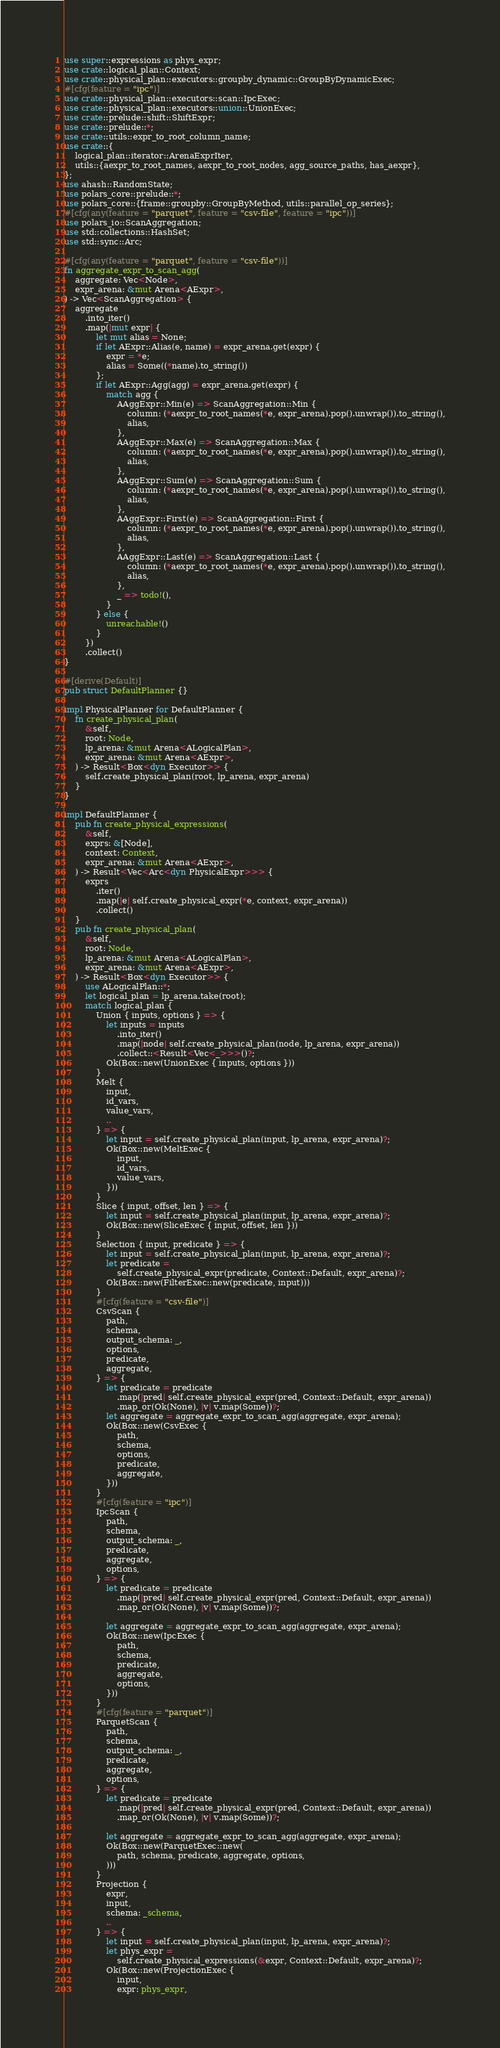<code> <loc_0><loc_0><loc_500><loc_500><_Rust_>use super::expressions as phys_expr;
use crate::logical_plan::Context;
use crate::physical_plan::executors::groupby_dynamic::GroupByDynamicExec;
#[cfg(feature = "ipc")]
use crate::physical_plan::executors::scan::IpcExec;
use crate::physical_plan::executors::union::UnionExec;
use crate::prelude::shift::ShiftExpr;
use crate::prelude::*;
use crate::utils::expr_to_root_column_name;
use crate::{
    logical_plan::iterator::ArenaExprIter,
    utils::{aexpr_to_root_names, aexpr_to_root_nodes, agg_source_paths, has_aexpr},
};
use ahash::RandomState;
use polars_core::prelude::*;
use polars_core::{frame::groupby::GroupByMethod, utils::parallel_op_series};
#[cfg(any(feature = "parquet", feature = "csv-file", feature = "ipc"))]
use polars_io::ScanAggregation;
use std::collections::HashSet;
use std::sync::Arc;

#[cfg(any(feature = "parquet", feature = "csv-file"))]
fn aggregate_expr_to_scan_agg(
    aggregate: Vec<Node>,
    expr_arena: &mut Arena<AExpr>,
) -> Vec<ScanAggregation> {
    aggregate
        .into_iter()
        .map(|mut expr| {
            let mut alias = None;
            if let AExpr::Alias(e, name) = expr_arena.get(expr) {
                expr = *e;
                alias = Some((*name).to_string())
            };
            if let AExpr::Agg(agg) = expr_arena.get(expr) {
                match agg {
                    AAggExpr::Min(e) => ScanAggregation::Min {
                        column: (*aexpr_to_root_names(*e, expr_arena).pop().unwrap()).to_string(),
                        alias,
                    },
                    AAggExpr::Max(e) => ScanAggregation::Max {
                        column: (*aexpr_to_root_names(*e, expr_arena).pop().unwrap()).to_string(),
                        alias,
                    },
                    AAggExpr::Sum(e) => ScanAggregation::Sum {
                        column: (*aexpr_to_root_names(*e, expr_arena).pop().unwrap()).to_string(),
                        alias,
                    },
                    AAggExpr::First(e) => ScanAggregation::First {
                        column: (*aexpr_to_root_names(*e, expr_arena).pop().unwrap()).to_string(),
                        alias,
                    },
                    AAggExpr::Last(e) => ScanAggregation::Last {
                        column: (*aexpr_to_root_names(*e, expr_arena).pop().unwrap()).to_string(),
                        alias,
                    },
                    _ => todo!(),
                }
            } else {
                unreachable!()
            }
        })
        .collect()
}

#[derive(Default)]
pub struct DefaultPlanner {}

impl PhysicalPlanner for DefaultPlanner {
    fn create_physical_plan(
        &self,
        root: Node,
        lp_arena: &mut Arena<ALogicalPlan>,
        expr_arena: &mut Arena<AExpr>,
    ) -> Result<Box<dyn Executor>> {
        self.create_physical_plan(root, lp_arena, expr_arena)
    }
}

impl DefaultPlanner {
    pub fn create_physical_expressions(
        &self,
        exprs: &[Node],
        context: Context,
        expr_arena: &mut Arena<AExpr>,
    ) -> Result<Vec<Arc<dyn PhysicalExpr>>> {
        exprs
            .iter()
            .map(|e| self.create_physical_expr(*e, context, expr_arena))
            .collect()
    }
    pub fn create_physical_plan(
        &self,
        root: Node,
        lp_arena: &mut Arena<ALogicalPlan>,
        expr_arena: &mut Arena<AExpr>,
    ) -> Result<Box<dyn Executor>> {
        use ALogicalPlan::*;
        let logical_plan = lp_arena.take(root);
        match logical_plan {
            Union { inputs, options } => {
                let inputs = inputs
                    .into_iter()
                    .map(|node| self.create_physical_plan(node, lp_arena, expr_arena))
                    .collect::<Result<Vec<_>>>()?;
                Ok(Box::new(UnionExec { inputs, options }))
            }
            Melt {
                input,
                id_vars,
                value_vars,
                ..
            } => {
                let input = self.create_physical_plan(input, lp_arena, expr_arena)?;
                Ok(Box::new(MeltExec {
                    input,
                    id_vars,
                    value_vars,
                }))
            }
            Slice { input, offset, len } => {
                let input = self.create_physical_plan(input, lp_arena, expr_arena)?;
                Ok(Box::new(SliceExec { input, offset, len }))
            }
            Selection { input, predicate } => {
                let input = self.create_physical_plan(input, lp_arena, expr_arena)?;
                let predicate =
                    self.create_physical_expr(predicate, Context::Default, expr_arena)?;
                Ok(Box::new(FilterExec::new(predicate, input)))
            }
            #[cfg(feature = "csv-file")]
            CsvScan {
                path,
                schema,
                output_schema: _,
                options,
                predicate,
                aggregate,
            } => {
                let predicate = predicate
                    .map(|pred| self.create_physical_expr(pred, Context::Default, expr_arena))
                    .map_or(Ok(None), |v| v.map(Some))?;
                let aggregate = aggregate_expr_to_scan_agg(aggregate, expr_arena);
                Ok(Box::new(CsvExec {
                    path,
                    schema,
                    options,
                    predicate,
                    aggregate,
                }))
            }
            #[cfg(feature = "ipc")]
            IpcScan {
                path,
                schema,
                output_schema: _,
                predicate,
                aggregate,
                options,
            } => {
                let predicate = predicate
                    .map(|pred| self.create_physical_expr(pred, Context::Default, expr_arena))
                    .map_or(Ok(None), |v| v.map(Some))?;

                let aggregate = aggregate_expr_to_scan_agg(aggregate, expr_arena);
                Ok(Box::new(IpcExec {
                    path,
                    schema,
                    predicate,
                    aggregate,
                    options,
                }))
            }
            #[cfg(feature = "parquet")]
            ParquetScan {
                path,
                schema,
                output_schema: _,
                predicate,
                aggregate,
                options,
            } => {
                let predicate = predicate
                    .map(|pred| self.create_physical_expr(pred, Context::Default, expr_arena))
                    .map_or(Ok(None), |v| v.map(Some))?;

                let aggregate = aggregate_expr_to_scan_agg(aggregate, expr_arena);
                Ok(Box::new(ParquetExec::new(
                    path, schema, predicate, aggregate, options,
                )))
            }
            Projection {
                expr,
                input,
                schema: _schema,
                ..
            } => {
                let input = self.create_physical_plan(input, lp_arena, expr_arena)?;
                let phys_expr =
                    self.create_physical_expressions(&expr, Context::Default, expr_arena)?;
                Ok(Box::new(ProjectionExec {
                    input,
                    expr: phys_expr,</code> 